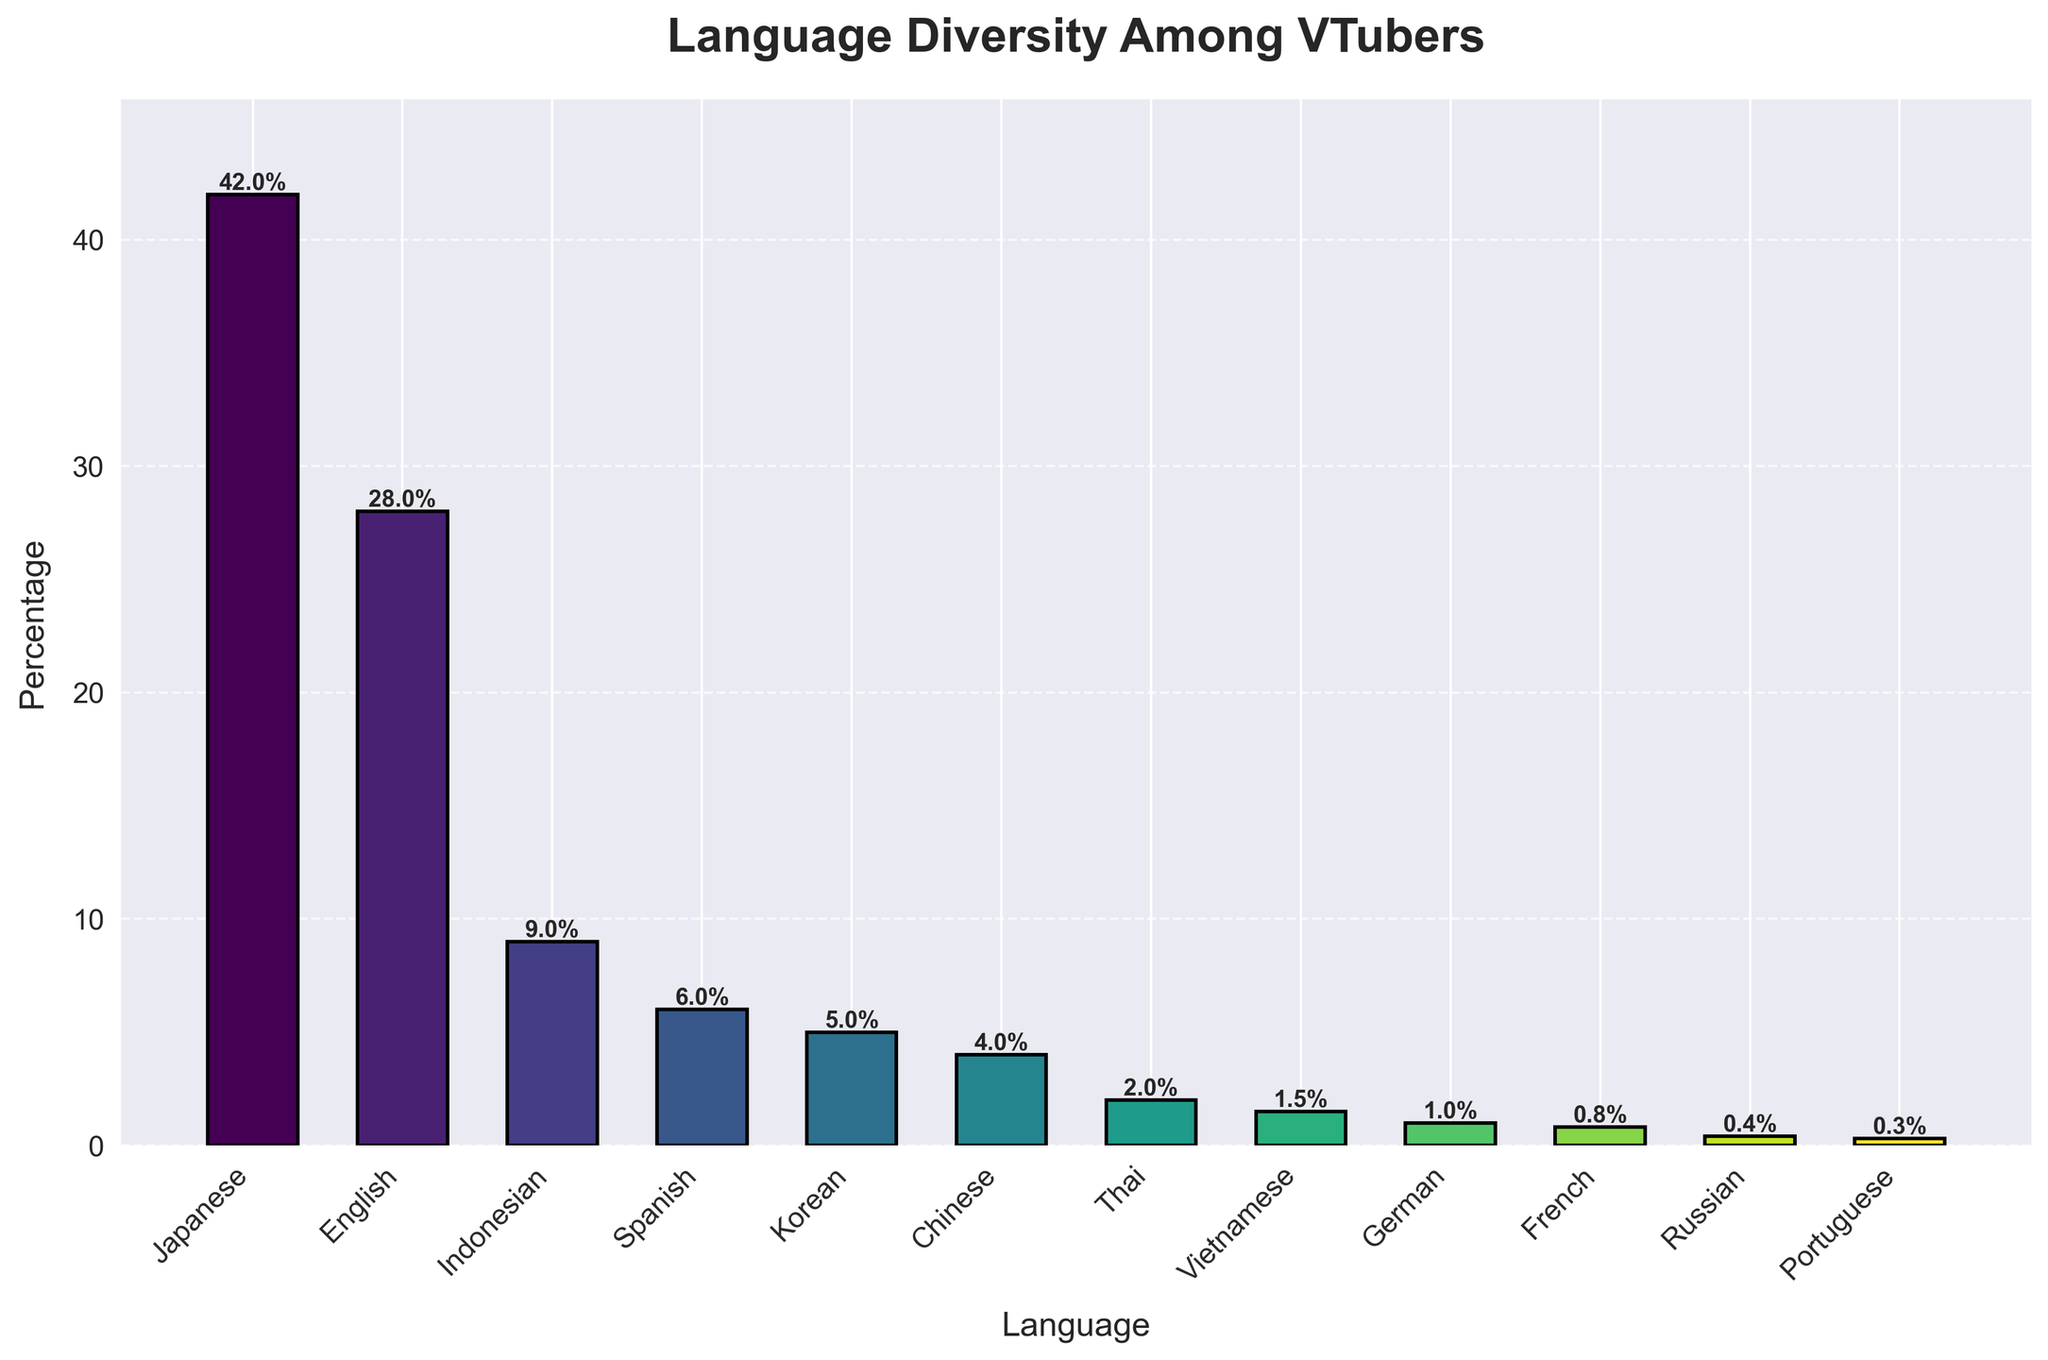What's the primary streaming language with the highest percentage among VTubers? The height of the bar for Japanese is the tallest, indicating it has the highest percentage.
Answer: Japanese What is the combined percentage of VTubers who primarily stream in Japanese and English? The Japanese percentage is 42% and the English percentage is 28%. Adding them together gives 42% + 28% = 70%.
Answer: 70% Which language has a lower percentage of VTubers, Korean or Chinese? By comparing the bars for Korean and Chinese, the Korean bar is slightly taller at 5%, while the Chinese bar is 4%.
Answer: Chinese What is the percentage difference between English and Indonesian VTubers? The percentage for English is 28% while for Indonesian it is 9%. The difference is 28% - 9% = 19%.
Answer: 19% How many languages have a percentage greater than 5%? The languages with bars taller than 5% are Japanese (42%), English (28%), and Indonesian (9%), totaling 3 languages.
Answer: 3 What is the average percentage of VTubers for the bottom five languages? The percentages for the bottom five languages are French (0.8%), Russian (0.4%), Portuguese (0.3%), Vietnamese (1.5%), and German (1%). Adding them gives 0.8% + 0.4% + 0.3% + 1.5% + 1% = 4%. Dividing by 5 gives 4% / 5 = 0.8%.
Answer: 0.8% Which language group, from the top four languages, has the smallest percentage and what is it? The top four languages are Japanese (42%), English (28%), Indonesian (9%), and Spanish (6%). The smallest percentage among these is Spanish with 6%.
Answer: Spanish, 6% What visual cues indicate the primary streaming language with the least percentage among VTubers? The shortest bar in the chart represents Russian with a percentage of 0.4%, visually indicating it has the least percentage.
Answer: Russian What is the total percentage of VTubers who stream primarily in non-Asian languages? The non-Asian languages in the chart are English (28%), Spanish (6%), German (1%), French (0.8%), Russian (0.4%), and Portuguese (0.3%). Summing these gives 28% + 6% + 1% + 0.8% + 0.4% + 0.3% = 36.5%.
Answer: 36.5% 